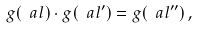<formula> <loc_0><loc_0><loc_500><loc_500>g ( \ a l ) \cdot g ( \ a l ^ { \prime } ) = g ( \ a l ^ { \prime \prime } ) \, ,</formula> 